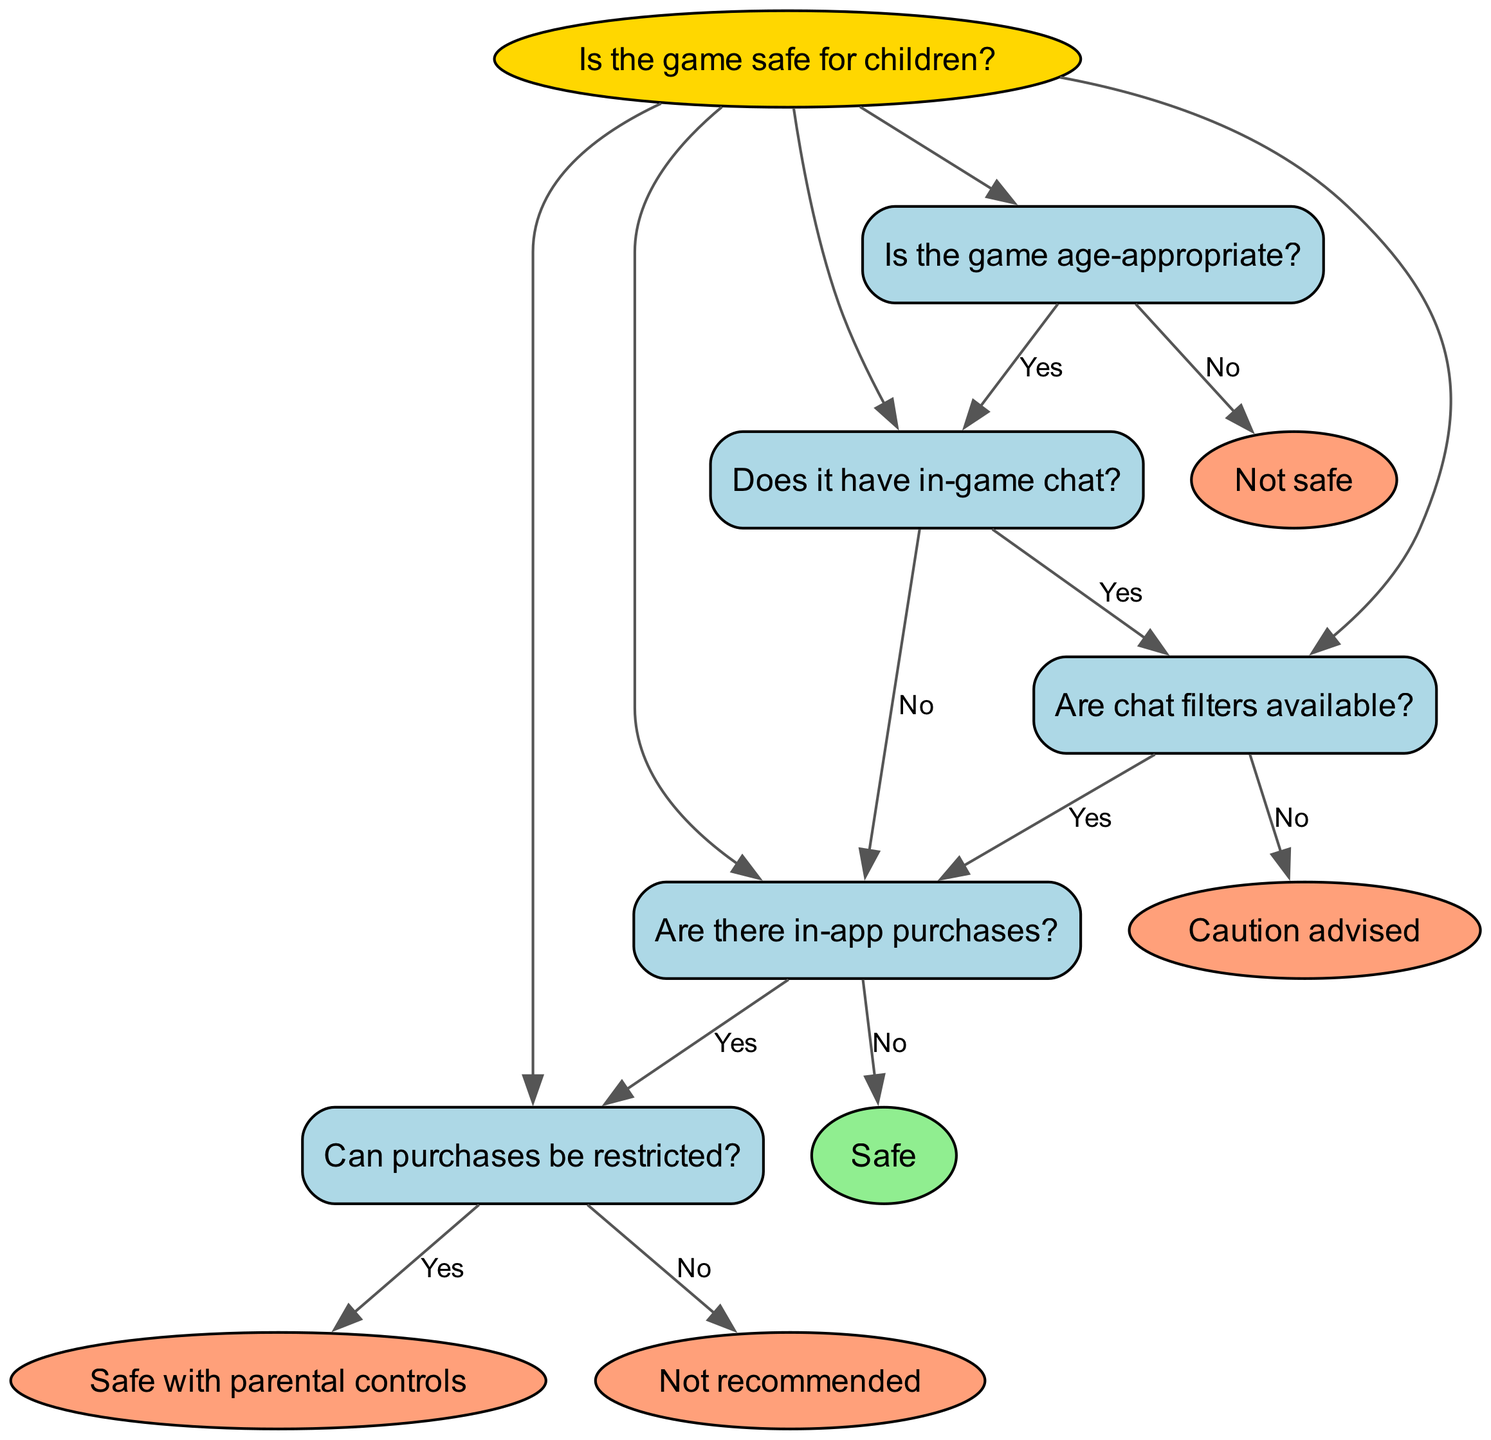What is the root question of the decision tree? The root question is specifically set at the top of the diagram, which is about assessing the safety of online games for children. This is clearly stated as "Is the game safe for children?"
Answer: Is the game safe for children? How many nodes are in the decision tree? Counting each individual node, including the root, the tree has a total of 6 nodes: 1 root node and 5 additional nodes related to the questions and results.
Answer: 6 What is the result if the game is not age-appropriate? Following the first branch from the root, if the game is determined to be not age-appropriate, the result stated is "Not safe." This directly leads from the relevant question in the decision tree.
Answer: Not safe What is the answer if the game has in-game chat but no chat filters available? From the decision path, if the game has in-game chat and no chat filters, the flow leads to the result "Caution advised." This outcome is indicated after evaluating the available chat features.
Answer: Caution advised What happens if the game has in-app purchases but those purchases cannot be restricted? The decision path shows that if in-app purchases exist and they cannot be restricted, the result specified is "Not recommended." This denotes potential risks associated with unrestricted purchases.
Answer: Not recommended What are the two outcomes if the game is safe with parental controls? Following the decision logic, if the game has chat features and restrictable in-app purchases, the final result is "Safe with parental controls." This assures safety when proper measures are in place.
Answer: Safe with parental controls How does the presence of in-app purchases affect the overall safety evaluation? The presence of in-app purchases is a critical factor in the decision tree. If they are present, the next determination focuses on whether those purchases can be restricted, influencing whether the outcome is "Safe", "Safe with parental controls", or "Not recommended". Thus, they create a branching point for safety evaluation.
Answer: Determines further evaluation Which question leads directly to assessing chat filters? The question that leads directly to assessing chat filters is "Does it have in-game chat?" This is where the decision on chat limitations begins, branching into the next assessment of filter availability.
Answer: Does it have in-game chat? What indicates that a game is safe? A game is indicated to be safe if it is age-appropriate, has in-game chat without needing filters or has no in-app purchases directly, leading to the result "Safe". This signifies conditions spelled out through the tree’s paths.
Answer: Safe 